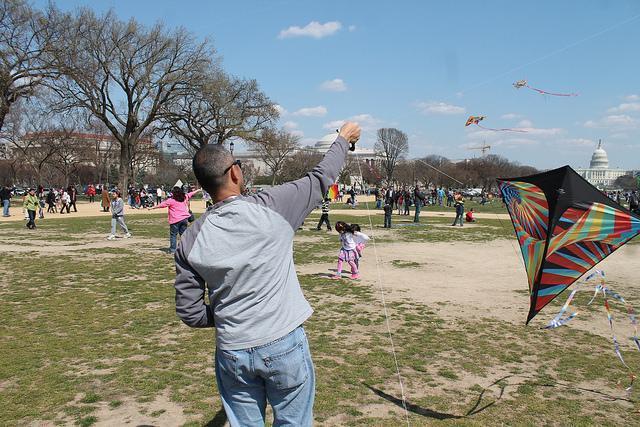How many kites are here?
Give a very brief answer. 3. How many of the man's arms are in the air?
Give a very brief answer. 1. How many humans are in the foreground of the picture?
Give a very brief answer. 1. How many people are there?
Give a very brief answer. 2. 